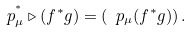Convert formula to latex. <formula><loc_0><loc_0><loc_500><loc_500>\ p ^ { ^ { * } } _ { \mu } \triangleright ( f ^ { * } g ) = \left ( \ p _ { \mu } ( f ^ { * } g ) \right ) .</formula> 